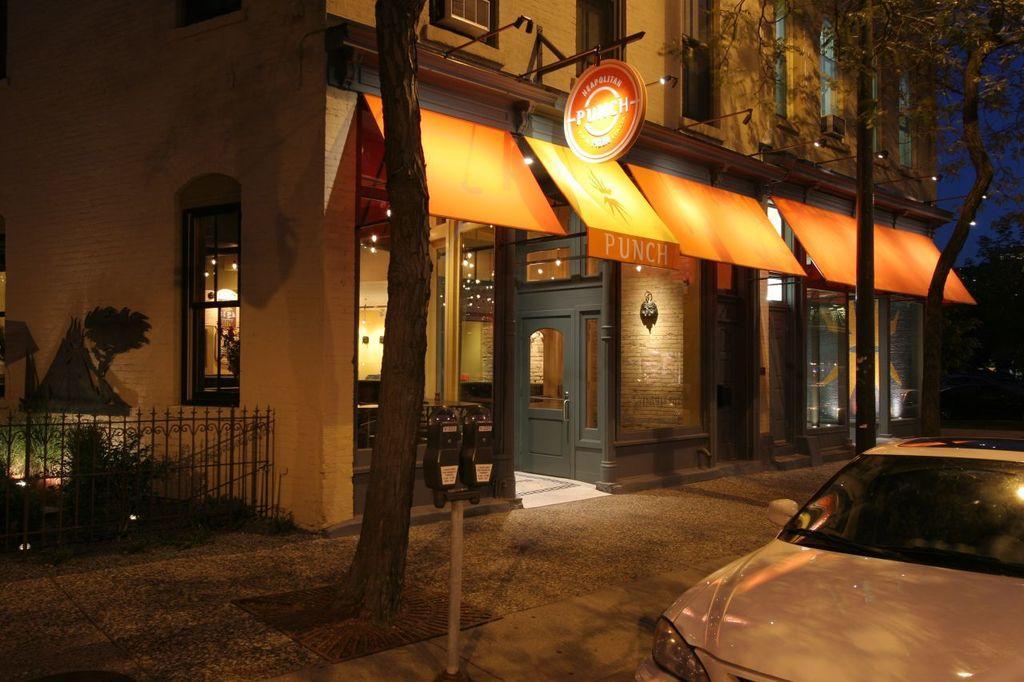How would you summarize this image in a sentence or two? In this image I can see a building, trees, pole, boards, lights, plants, grille, windows, vehicle, sky, device, door and objects. 